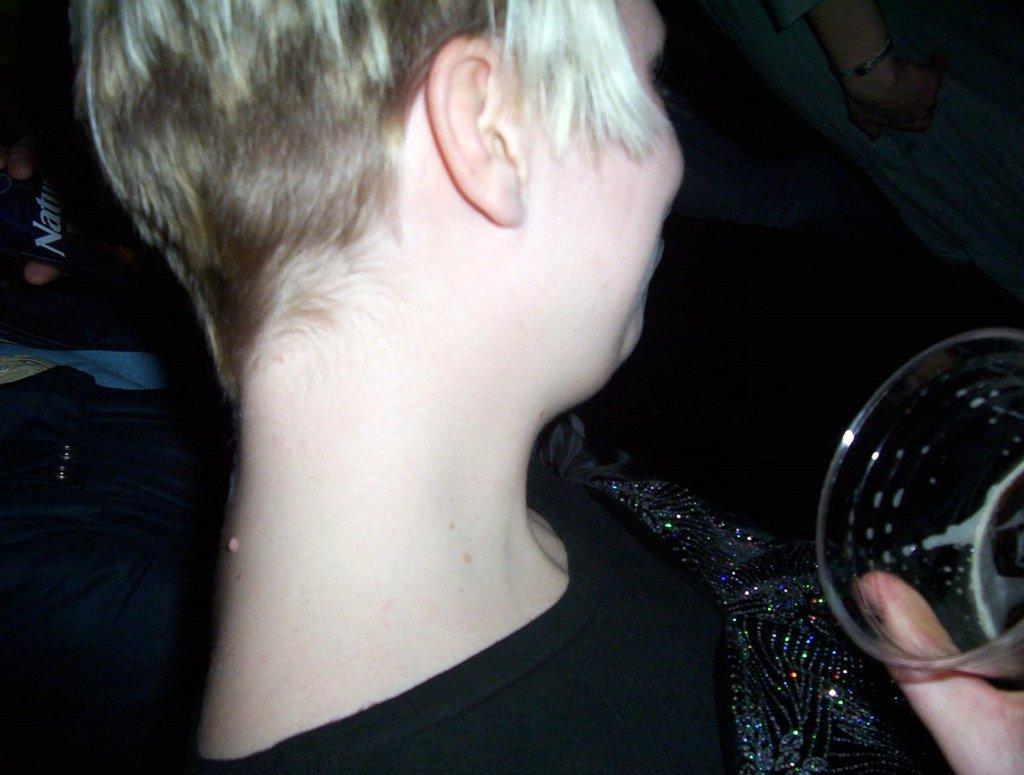Can you describe this image briefly? In this picture we can see a person holding a glass with hand and in the background we can see some persons. 